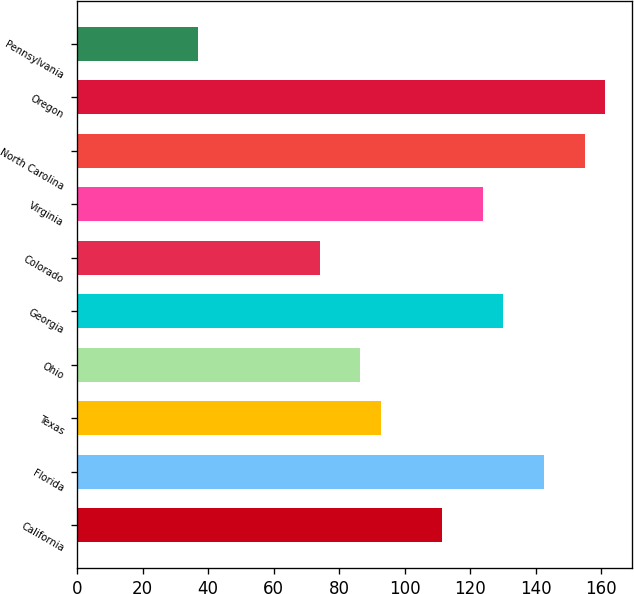Convert chart. <chart><loc_0><loc_0><loc_500><loc_500><bar_chart><fcel>California<fcel>Florida<fcel>Texas<fcel>Ohio<fcel>Georgia<fcel>Colorado<fcel>Virginia<fcel>North Carolina<fcel>Oregon<fcel>Pennsylvania<nl><fcel>111.41<fcel>142.56<fcel>92.72<fcel>86.49<fcel>130.1<fcel>74.03<fcel>123.87<fcel>155.02<fcel>161.25<fcel>37<nl></chart> 